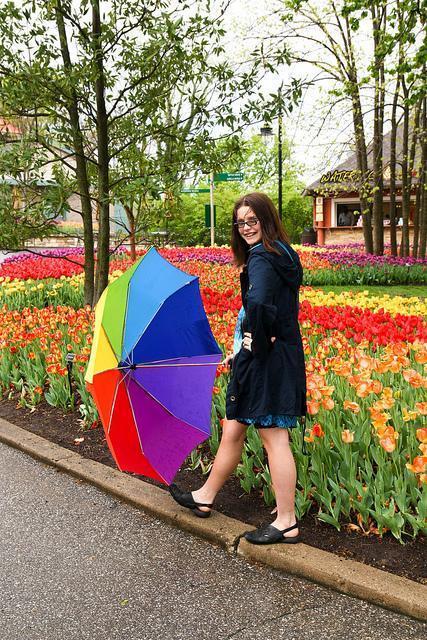How many colors are on the umbrella?
Give a very brief answer. 8. How many blue box by the red couch and located on the left of the coffee table ?
Give a very brief answer. 0. 